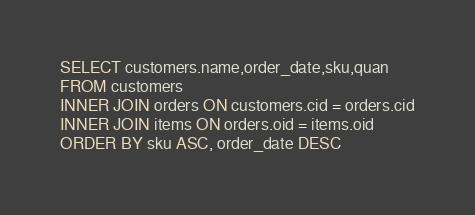<code> <loc_0><loc_0><loc_500><loc_500><_SQL_>SELECT customers.name,order_date,sku,quan
FROM customers
INNER JOIN orders ON customers.cid = orders.cid
INNER JOIN items ON orders.oid = items.oid
ORDER BY sku ASC, order_date DESC
</code> 